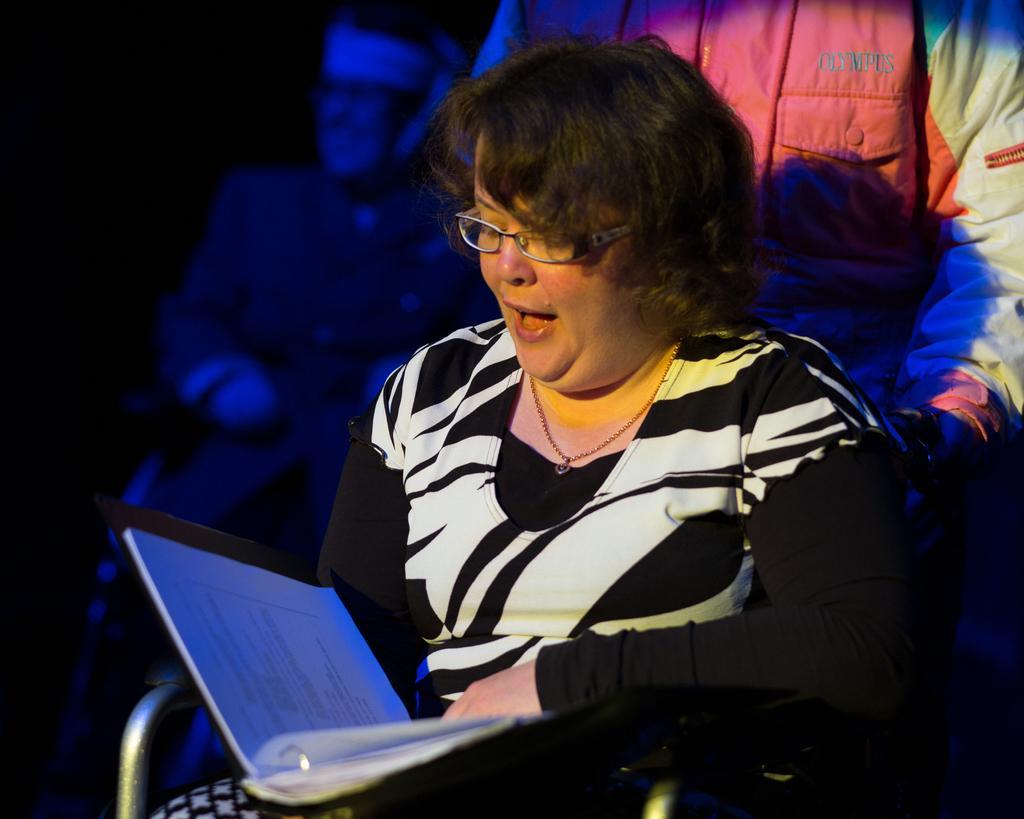In one or two sentences, can you explain what this image depicts? In this image there is a lady sitting on the chair and reading a book, behind her there are few persons in the dark. 